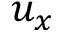<formula> <loc_0><loc_0><loc_500><loc_500>u _ { x }</formula> 